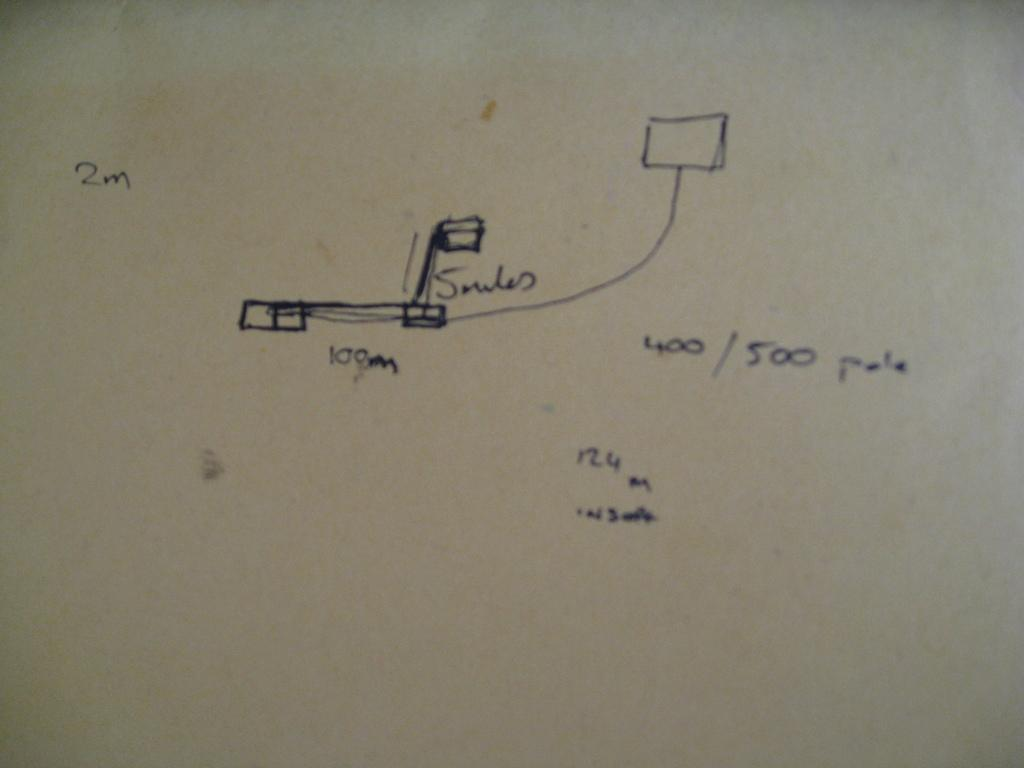<image>
Relay a brief, clear account of the picture shown. A sheet of paper shows a scribbles and a diagram measured in meters. 